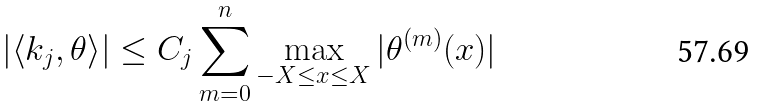Convert formula to latex. <formula><loc_0><loc_0><loc_500><loc_500>\left | \left < k _ { j } , \theta \right > \right | \leq C _ { j } \sum _ { m = 0 } ^ { n } \max _ { - X \leq x \leq X } | \theta ^ { ( m ) } ( x ) |</formula> 